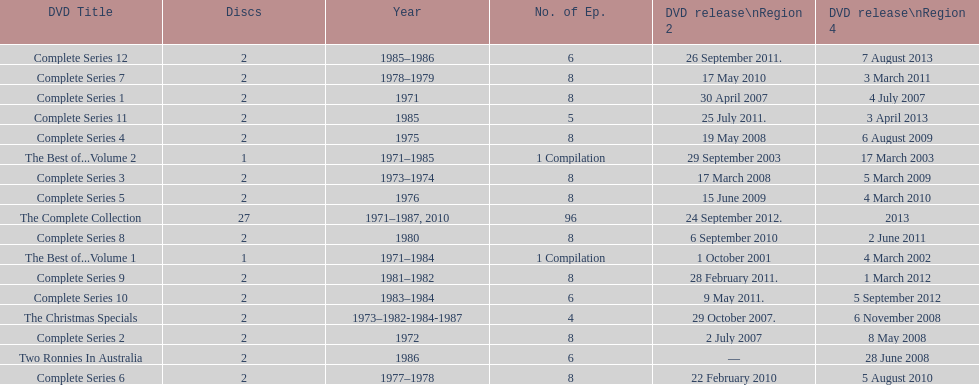True or false. the television show "the two ronnies" featured more than 10 episodes in a season. False. 